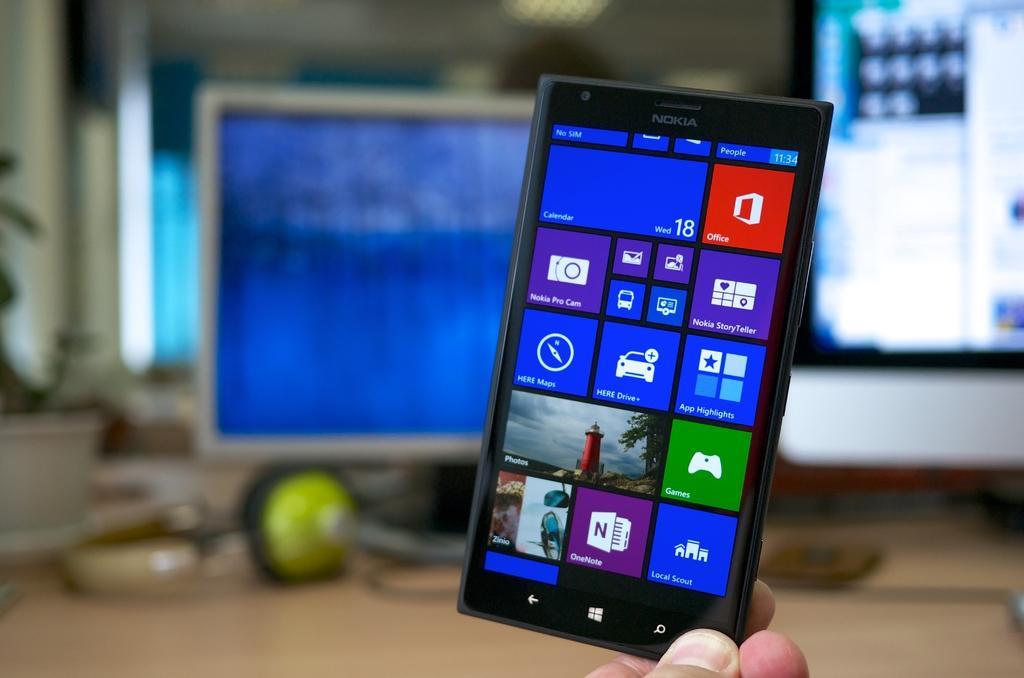How would you summarize this image in a sentence or two? In this picture, we can see a person hand holding a mobile phone, and we can see the blurred background, and we can see some blurred objects like screen and some connected devices to it, and we can see some objects too. 